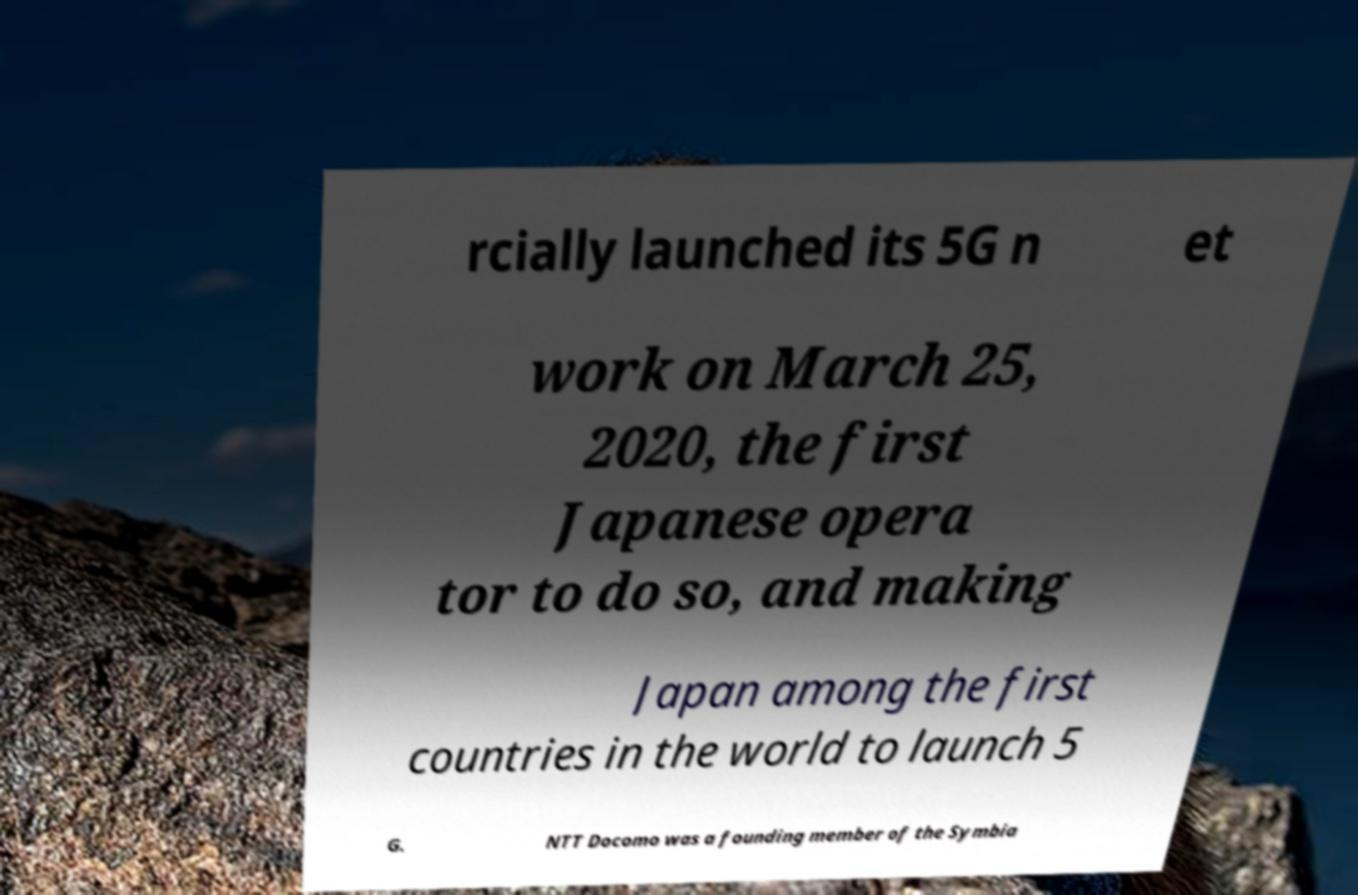For documentation purposes, I need the text within this image transcribed. Could you provide that? rcially launched its 5G n et work on March 25, 2020, the first Japanese opera tor to do so, and making Japan among the first countries in the world to launch 5 G. NTT Docomo was a founding member of the Symbia 